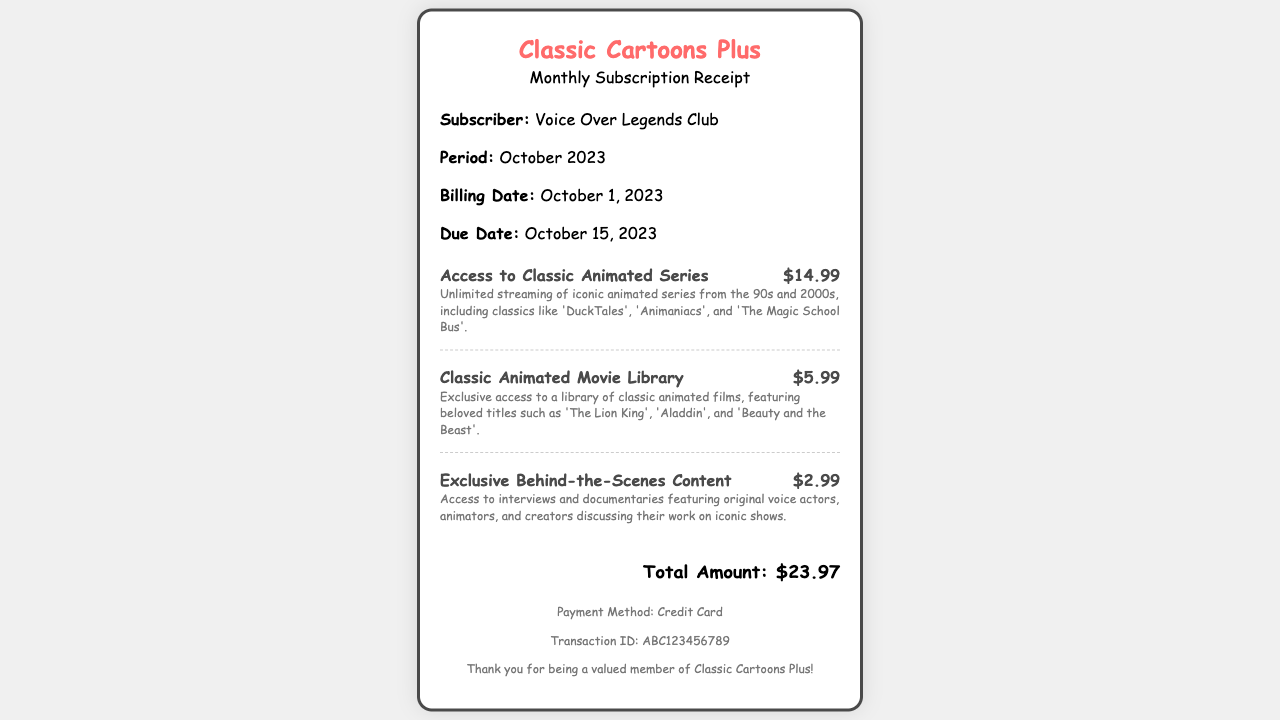What is the name of the subscription service? The name of the subscription service is prominently displayed at the top of the receipt.
Answer: Classic Cartoons Plus What is the total amount billed? The total amount billed is clearly indicated in the total section of the receipt.
Answer: $23.97 Who is the subscriber? The subscriber's name is mentioned in the details section of the receipt.
Answer: Voice Over Legends Club When is the billing date? The billing date can be found in the details section, indicating when the subscription was charged.
Answer: October 1, 2023 What services are included in the subscription? The services included in the subscription are listed with their prices in the subscription items section.
Answer: Access to Classic Animated Series, Classic Animated Movie Library, Exclusive Behind-the-Scenes Content What is the due date for the payment? The due date for the payment is specified in the details section of the receipt.
Answer: October 15, 2023 What payment method was used? The payment method is mentioned in the footer section of the receipt.
Answer: Credit Card How much does the access to classic animated series cost? The cost for access to classic animated series is indicated next to the title in the subscription items.
Answer: $14.99 What is the transaction ID? The transaction ID is included in the footer section for reference.
Answer: ABC123456789 